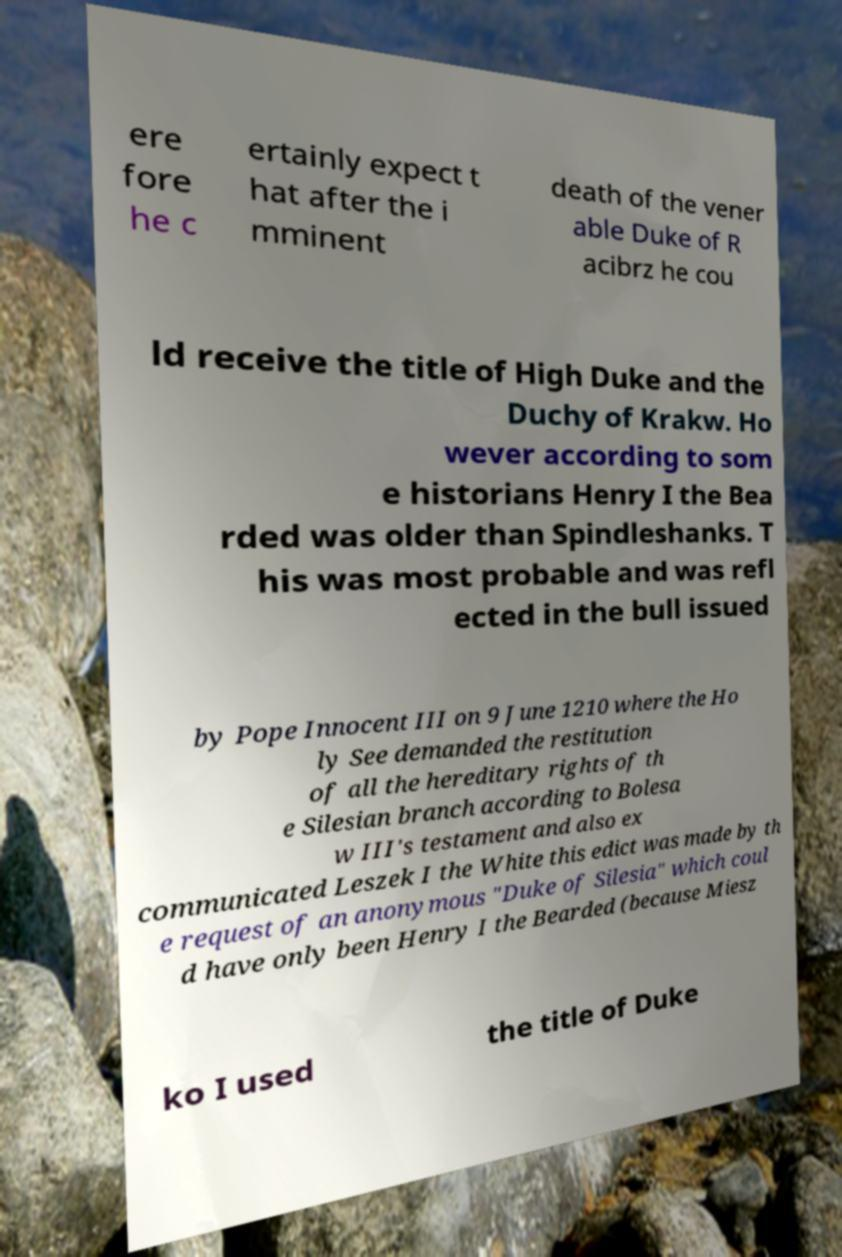I need the written content from this picture converted into text. Can you do that? ere fore he c ertainly expect t hat after the i mminent death of the vener able Duke of R acibrz he cou ld receive the title of High Duke and the Duchy of Krakw. Ho wever according to som e historians Henry I the Bea rded was older than Spindleshanks. T his was most probable and was refl ected in the bull issued by Pope Innocent III on 9 June 1210 where the Ho ly See demanded the restitution of all the hereditary rights of th e Silesian branch according to Bolesa w III's testament and also ex communicated Leszek I the White this edict was made by th e request of an anonymous "Duke of Silesia" which coul d have only been Henry I the Bearded (because Miesz ko I used the title of Duke 